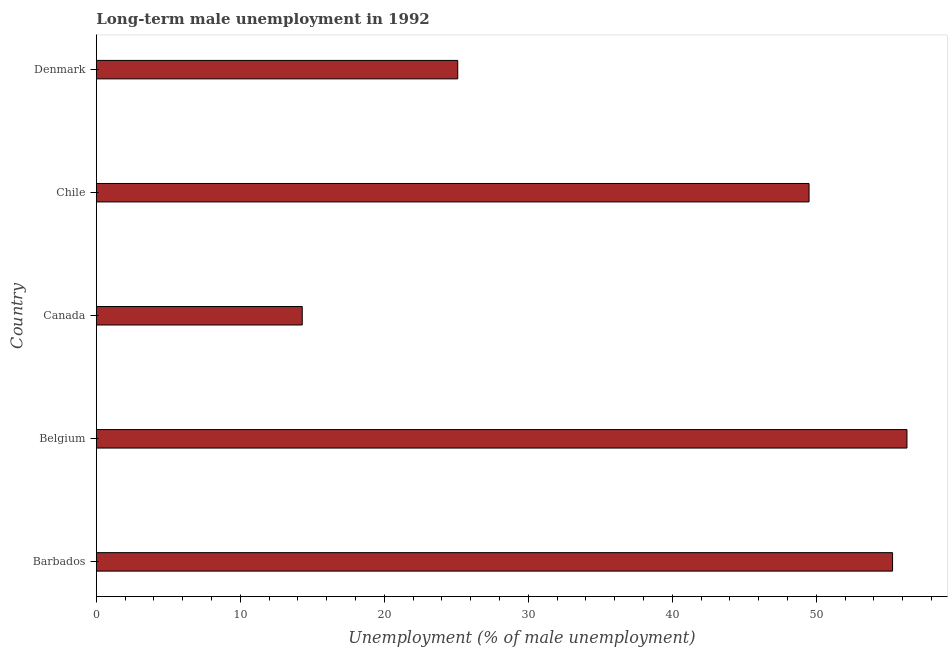Does the graph contain grids?
Keep it short and to the point. No. What is the title of the graph?
Keep it short and to the point. Long-term male unemployment in 1992. What is the label or title of the X-axis?
Keep it short and to the point. Unemployment (% of male unemployment). What is the label or title of the Y-axis?
Ensure brevity in your answer.  Country. What is the long-term male unemployment in Denmark?
Your answer should be compact. 25.1. Across all countries, what is the maximum long-term male unemployment?
Offer a terse response. 56.3. Across all countries, what is the minimum long-term male unemployment?
Your answer should be compact. 14.3. In which country was the long-term male unemployment maximum?
Provide a short and direct response. Belgium. What is the sum of the long-term male unemployment?
Provide a succinct answer. 200.5. What is the difference between the long-term male unemployment in Canada and Denmark?
Your answer should be compact. -10.8. What is the average long-term male unemployment per country?
Provide a succinct answer. 40.1. What is the median long-term male unemployment?
Offer a terse response. 49.5. What is the ratio of the long-term male unemployment in Canada to that in Chile?
Your response must be concise. 0.29. What is the difference between the highest and the second highest long-term male unemployment?
Ensure brevity in your answer.  1. Are the values on the major ticks of X-axis written in scientific E-notation?
Ensure brevity in your answer.  No. What is the Unemployment (% of male unemployment) in Barbados?
Your answer should be compact. 55.3. What is the Unemployment (% of male unemployment) in Belgium?
Make the answer very short. 56.3. What is the Unemployment (% of male unemployment) in Canada?
Keep it short and to the point. 14.3. What is the Unemployment (% of male unemployment) in Chile?
Offer a very short reply. 49.5. What is the Unemployment (% of male unemployment) in Denmark?
Offer a very short reply. 25.1. What is the difference between the Unemployment (% of male unemployment) in Barbados and Denmark?
Provide a short and direct response. 30.2. What is the difference between the Unemployment (% of male unemployment) in Belgium and Chile?
Make the answer very short. 6.8. What is the difference between the Unemployment (% of male unemployment) in Belgium and Denmark?
Provide a succinct answer. 31.2. What is the difference between the Unemployment (% of male unemployment) in Canada and Chile?
Your answer should be compact. -35.2. What is the difference between the Unemployment (% of male unemployment) in Canada and Denmark?
Give a very brief answer. -10.8. What is the difference between the Unemployment (% of male unemployment) in Chile and Denmark?
Your answer should be very brief. 24.4. What is the ratio of the Unemployment (% of male unemployment) in Barbados to that in Canada?
Make the answer very short. 3.87. What is the ratio of the Unemployment (% of male unemployment) in Barbados to that in Chile?
Your response must be concise. 1.12. What is the ratio of the Unemployment (% of male unemployment) in Barbados to that in Denmark?
Keep it short and to the point. 2.2. What is the ratio of the Unemployment (% of male unemployment) in Belgium to that in Canada?
Provide a succinct answer. 3.94. What is the ratio of the Unemployment (% of male unemployment) in Belgium to that in Chile?
Offer a very short reply. 1.14. What is the ratio of the Unemployment (% of male unemployment) in Belgium to that in Denmark?
Your answer should be compact. 2.24. What is the ratio of the Unemployment (% of male unemployment) in Canada to that in Chile?
Keep it short and to the point. 0.29. What is the ratio of the Unemployment (% of male unemployment) in Canada to that in Denmark?
Offer a terse response. 0.57. What is the ratio of the Unemployment (% of male unemployment) in Chile to that in Denmark?
Ensure brevity in your answer.  1.97. 